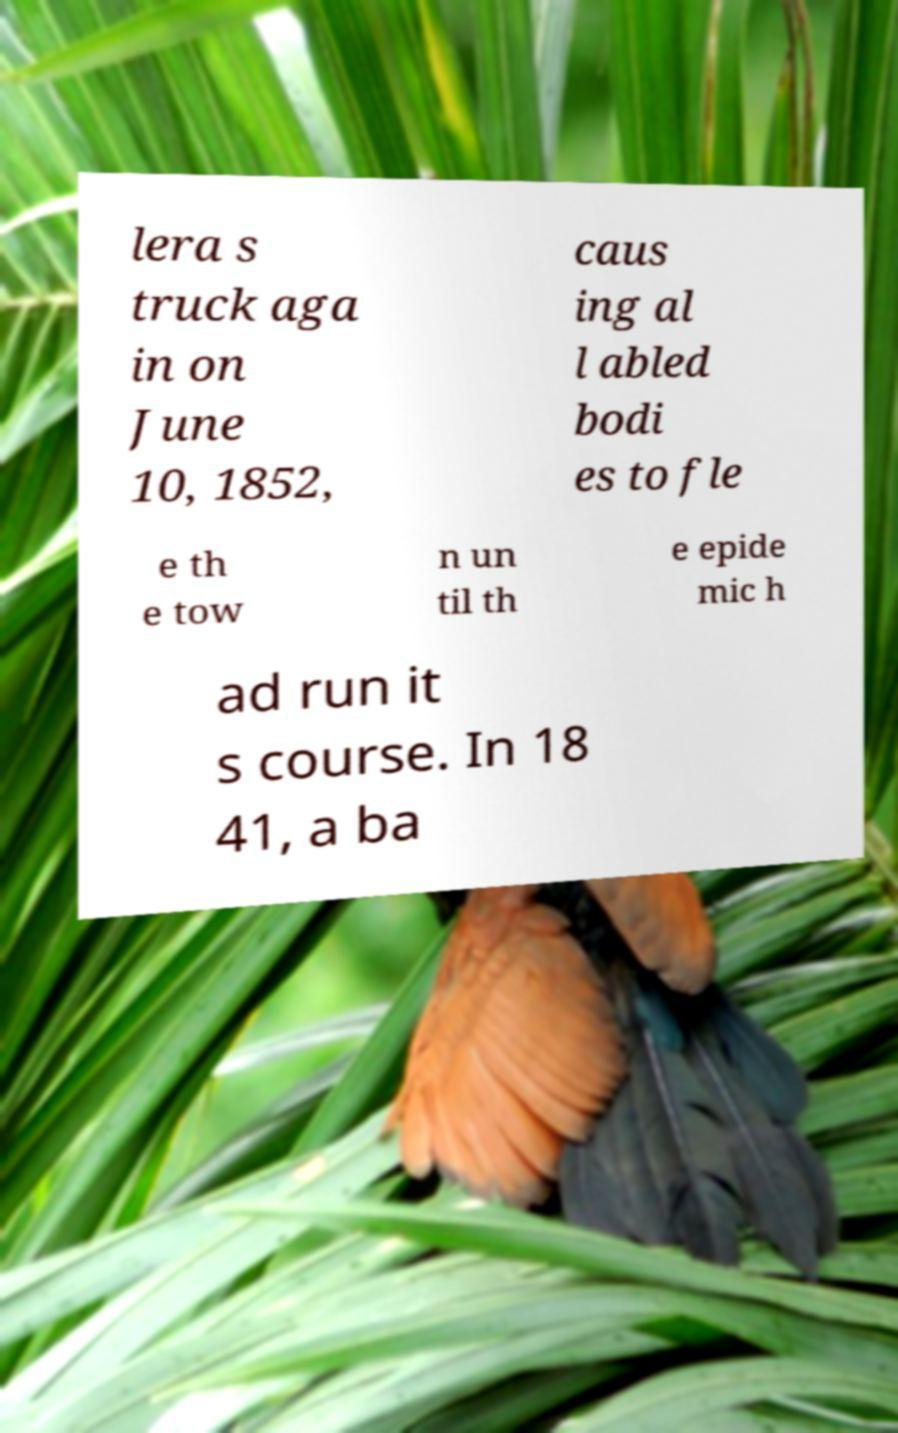What messages or text are displayed in this image? I need them in a readable, typed format. lera s truck aga in on June 10, 1852, caus ing al l abled bodi es to fle e th e tow n un til th e epide mic h ad run it s course. In 18 41, a ba 